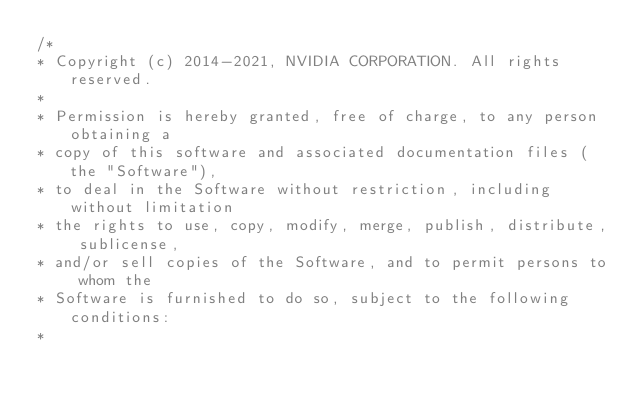Convert code to text. <code><loc_0><loc_0><loc_500><loc_500><_C++_>/*
* Copyright (c) 2014-2021, NVIDIA CORPORATION. All rights reserved.
*
* Permission is hereby granted, free of charge, to any person obtaining a
* copy of this software and associated documentation files (the "Software"),
* to deal in the Software without restriction, including without limitation
* the rights to use, copy, modify, merge, publish, distribute, sublicense,
* and/or sell copies of the Software, and to permit persons to whom the
* Software is furnished to do so, subject to the following conditions:
*</code> 